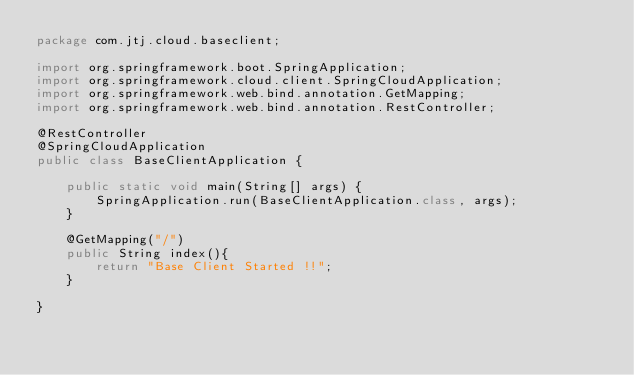Convert code to text. <code><loc_0><loc_0><loc_500><loc_500><_Java_>package com.jtj.cloud.baseclient;

import org.springframework.boot.SpringApplication;
import org.springframework.cloud.client.SpringCloudApplication;
import org.springframework.web.bind.annotation.GetMapping;
import org.springframework.web.bind.annotation.RestController;

@RestController
@SpringCloudApplication
public class BaseClientApplication {

	public static void main(String[] args) {
		SpringApplication.run(BaseClientApplication.class, args);
	}

	@GetMapping("/")
	public String index(){
		return "Base Client Started !!";
	}

}
</code> 